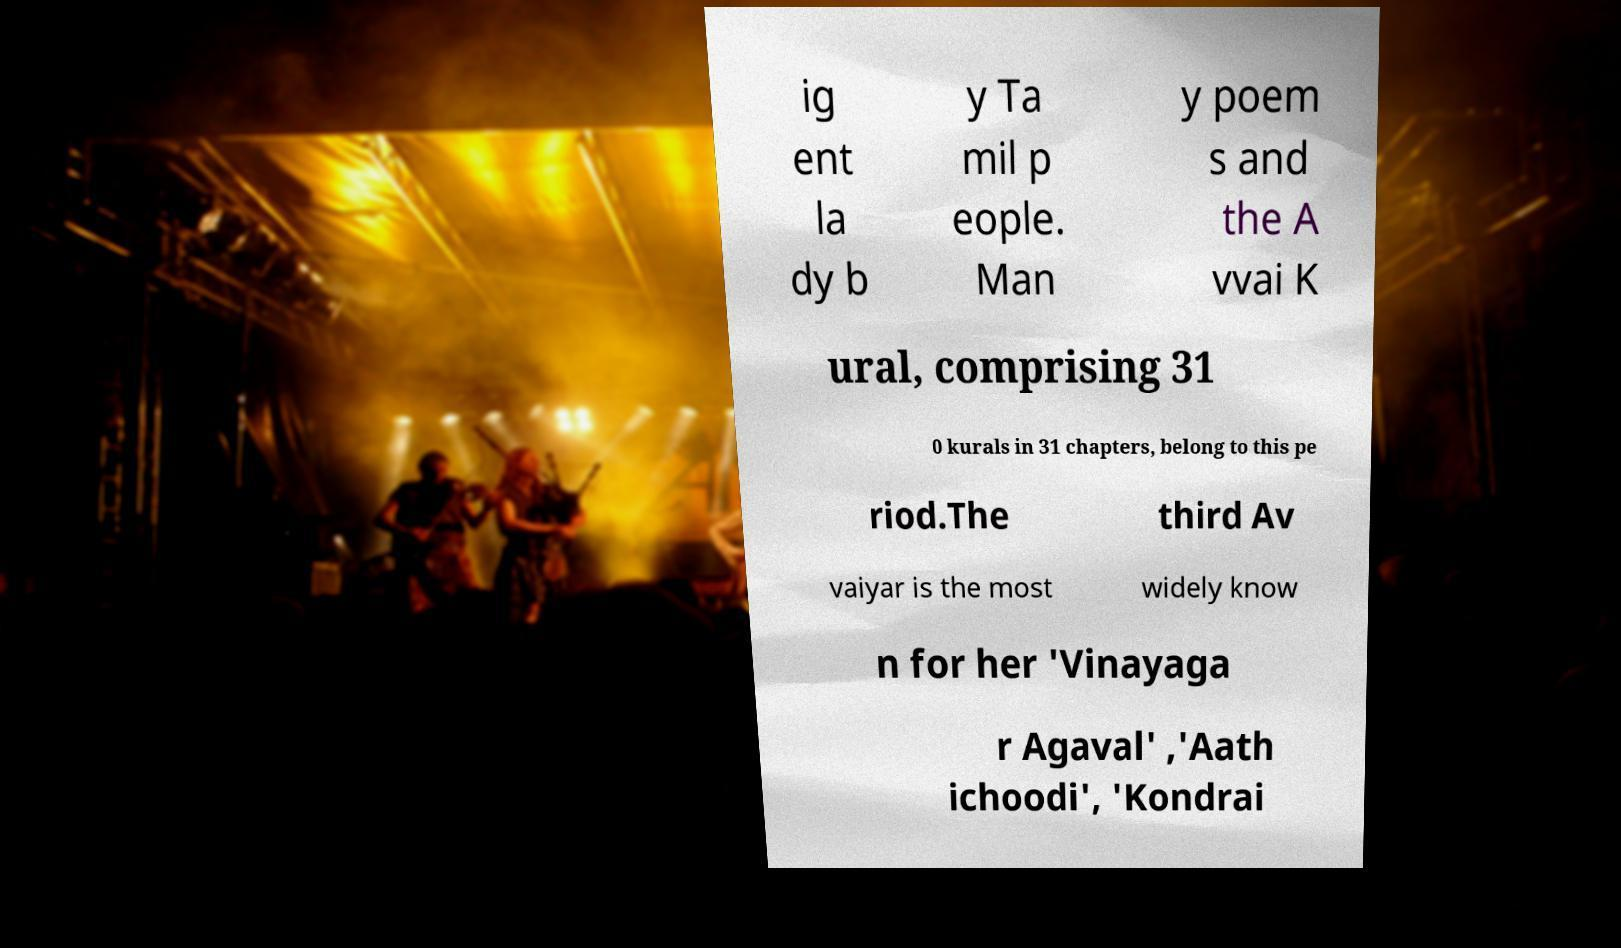For documentation purposes, I need the text within this image transcribed. Could you provide that? ig ent la dy b y Ta mil p eople. Man y poem s and the A vvai K ural, comprising 31 0 kurals in 31 chapters, belong to this pe riod.The third Av vaiyar is the most widely know n for her 'Vinayaga r Agaval' ,'Aath ichoodi', 'Kondrai 